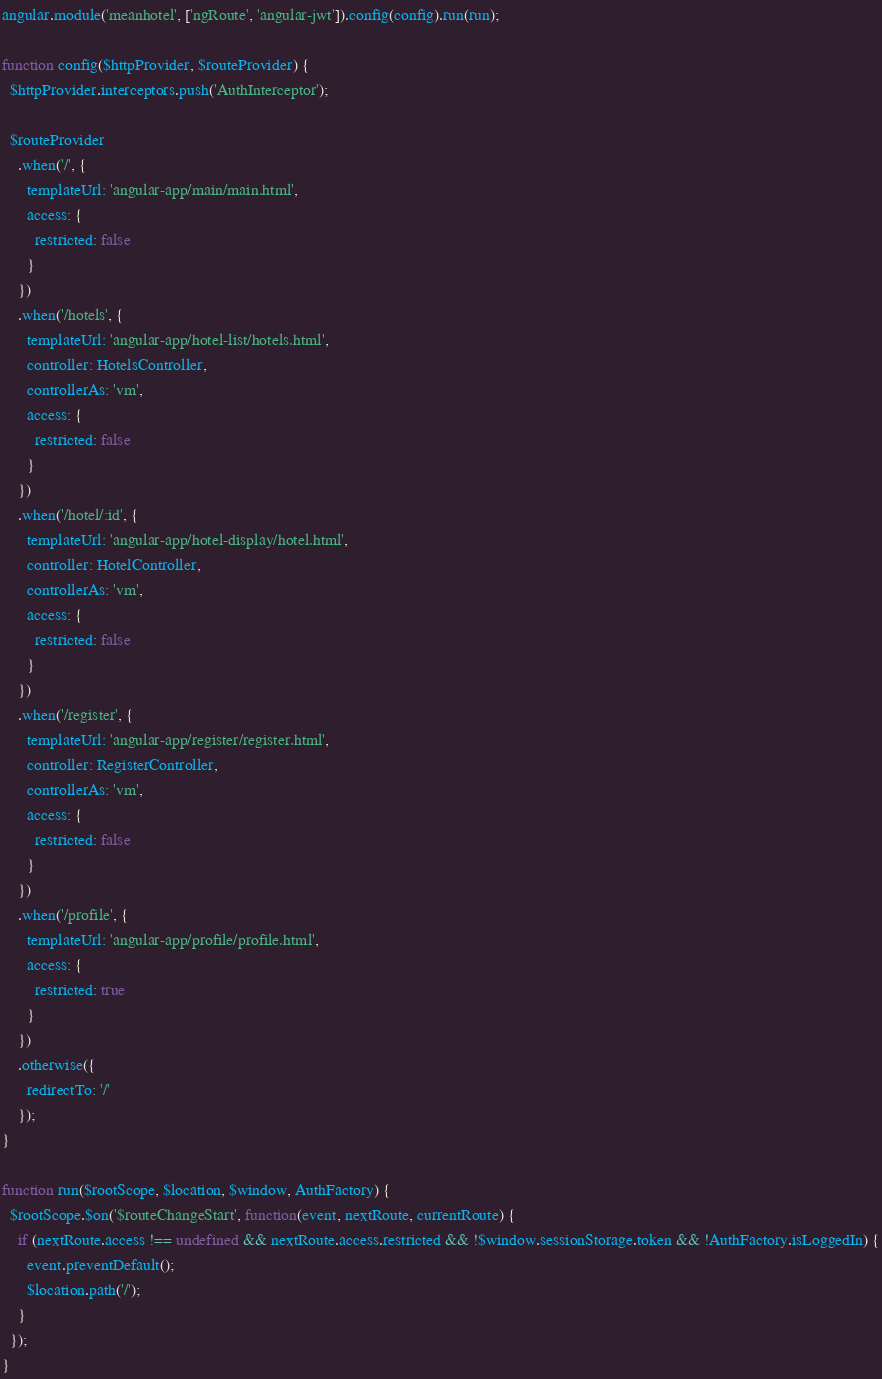<code> <loc_0><loc_0><loc_500><loc_500><_JavaScript_>angular.module('meanhotel', ['ngRoute', 'angular-jwt']).config(config).run(run);

function config($httpProvider, $routeProvider) {
  $httpProvider.interceptors.push('AuthInterceptor');
  
  $routeProvider
    .when('/', {
      templateUrl: 'angular-app/main/main.html',
      access: {
        restricted: false
      }
    })
    .when('/hotels', {
      templateUrl: 'angular-app/hotel-list/hotels.html',
      controller: HotelsController,
      controllerAs: 'vm',
      access: {
        restricted: false
      }
    })
    .when('/hotel/:id', {
      templateUrl: 'angular-app/hotel-display/hotel.html',
      controller: HotelController,
      controllerAs: 'vm',
      access: {
        restricted: false
      }
    })
    .when('/register', {
      templateUrl: 'angular-app/register/register.html',
      controller: RegisterController,
      controllerAs: 'vm',
      access: {
        restricted: false
      }
    })
    .when('/profile', {
      templateUrl: 'angular-app/profile/profile.html',
      access: {
        restricted: true
      }
    })
    .otherwise({
      redirectTo: '/'
    });
}

function run($rootScope, $location, $window, AuthFactory) {
  $rootScope.$on('$routeChangeStart', function(event, nextRoute, currentRoute) {
    if (nextRoute.access !== undefined && nextRoute.access.restricted && !$window.sessionStorage.token && !AuthFactory.isLoggedIn) {
      event.preventDefault();
      $location.path('/');
    }
  });
}</code> 